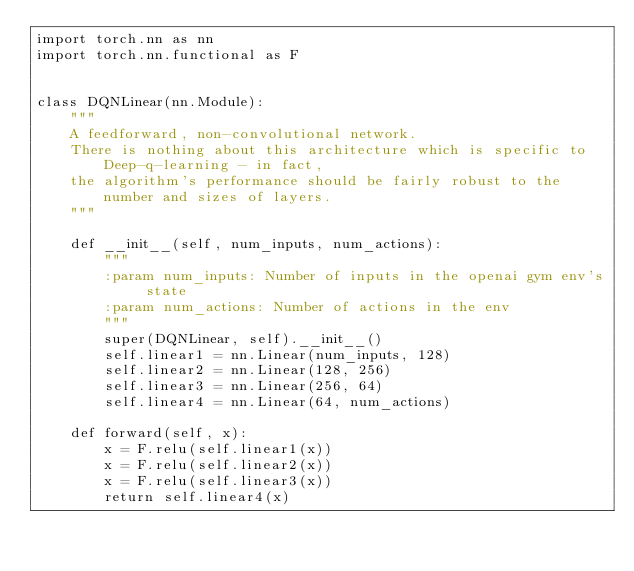<code> <loc_0><loc_0><loc_500><loc_500><_Python_>import torch.nn as nn
import torch.nn.functional as F


class DQNLinear(nn.Module):
    """
    A feedforward, non-convolutional network.
    There is nothing about this architecture which is specific to Deep-q-learning - in fact,
    the algorithm's performance should be fairly robust to the number and sizes of layers.
    """

    def __init__(self, num_inputs, num_actions):
        """
        :param num_inputs: Number of inputs in the openai gym env's state
        :param num_actions: Number of actions in the env
        """
        super(DQNLinear, self).__init__()
        self.linear1 = nn.Linear(num_inputs, 128)
        self.linear2 = nn.Linear(128, 256)
        self.linear3 = nn.Linear(256, 64)
        self.linear4 = nn.Linear(64, num_actions)

    def forward(self, x):
        x = F.relu(self.linear1(x))
        x = F.relu(self.linear2(x))
        x = F.relu(self.linear3(x))
        return self.linear4(x)
</code> 